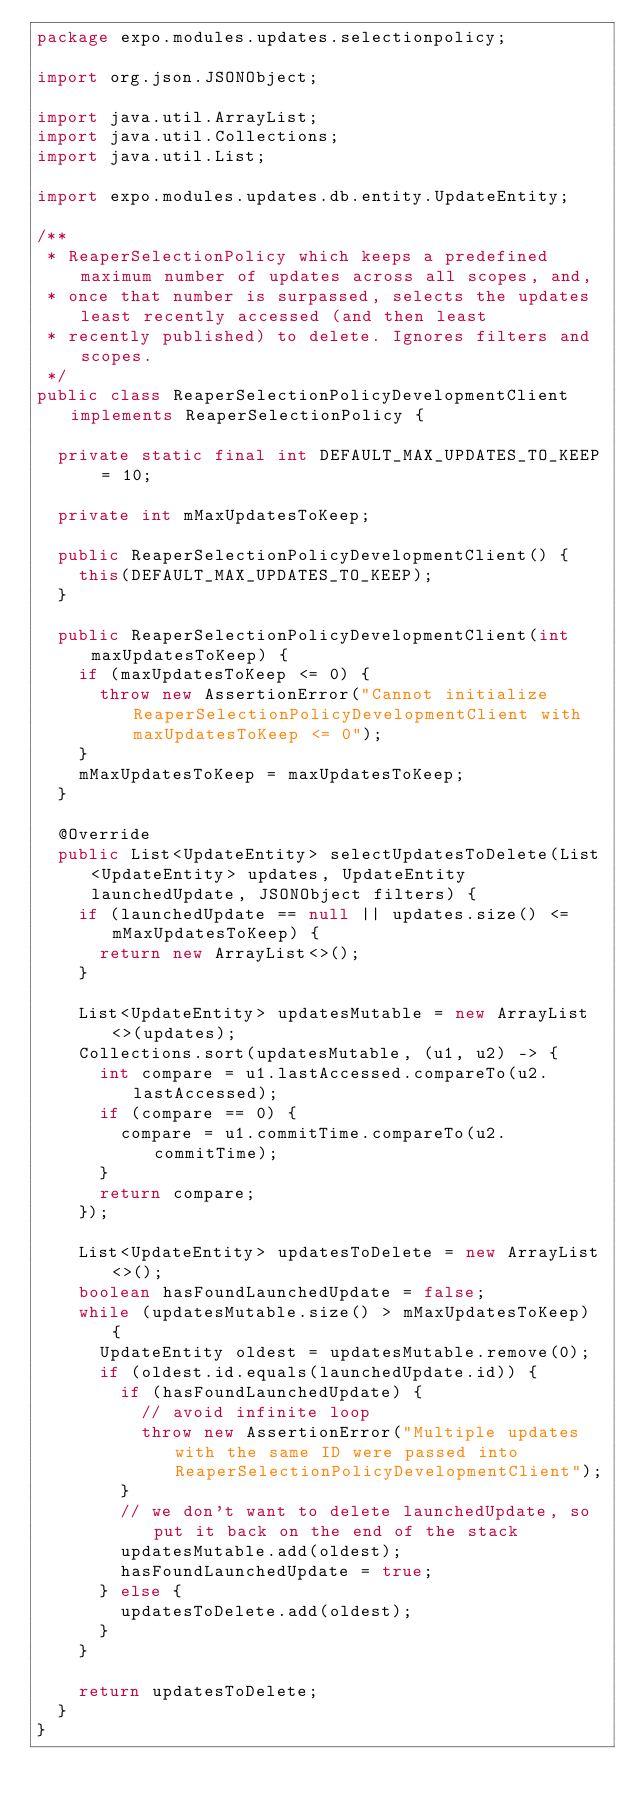Convert code to text. <code><loc_0><loc_0><loc_500><loc_500><_Java_>package expo.modules.updates.selectionpolicy;

import org.json.JSONObject;

import java.util.ArrayList;
import java.util.Collections;
import java.util.List;

import expo.modules.updates.db.entity.UpdateEntity;

/**
 * ReaperSelectionPolicy which keeps a predefined maximum number of updates across all scopes, and,
 * once that number is surpassed, selects the updates least recently accessed (and then least
 * recently published) to delete. Ignores filters and scopes.
 */
public class ReaperSelectionPolicyDevelopmentClient implements ReaperSelectionPolicy {

  private static final int DEFAULT_MAX_UPDATES_TO_KEEP = 10;

  private int mMaxUpdatesToKeep;

  public ReaperSelectionPolicyDevelopmentClient() {
    this(DEFAULT_MAX_UPDATES_TO_KEEP);
  }

  public ReaperSelectionPolicyDevelopmentClient(int maxUpdatesToKeep) {
    if (maxUpdatesToKeep <= 0) {
      throw new AssertionError("Cannot initialize ReaperSelectionPolicyDevelopmentClient with maxUpdatesToKeep <= 0");
    }
    mMaxUpdatesToKeep = maxUpdatesToKeep;
  }

  @Override
  public List<UpdateEntity> selectUpdatesToDelete(List<UpdateEntity> updates, UpdateEntity launchedUpdate, JSONObject filters) {
    if (launchedUpdate == null || updates.size() <= mMaxUpdatesToKeep) {
      return new ArrayList<>();
    }

    List<UpdateEntity> updatesMutable = new ArrayList<>(updates);
    Collections.sort(updatesMutable, (u1, u2) -> {
      int compare = u1.lastAccessed.compareTo(u2.lastAccessed);
      if (compare == 0) {
        compare = u1.commitTime.compareTo(u2.commitTime);
      }
      return compare;
    });

    List<UpdateEntity> updatesToDelete = new ArrayList<>();
    boolean hasFoundLaunchedUpdate = false;
    while (updatesMutable.size() > mMaxUpdatesToKeep) {
      UpdateEntity oldest = updatesMutable.remove(0);
      if (oldest.id.equals(launchedUpdate.id)) {
        if (hasFoundLaunchedUpdate) {
          // avoid infinite loop
          throw new AssertionError("Multiple updates with the same ID were passed into ReaperSelectionPolicyDevelopmentClient");
        }
        // we don't want to delete launchedUpdate, so put it back on the end of the stack
        updatesMutable.add(oldest);
        hasFoundLaunchedUpdate = true;
      } else {
        updatesToDelete.add(oldest);
      }
    }

    return updatesToDelete;
  }
}
</code> 